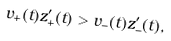<formula> <loc_0><loc_0><loc_500><loc_500>v _ { + } ( t ) z ^ { \prime } _ { + } ( t ) > v _ { - } ( t ) z ^ { \prime } _ { - } ( t ) ,</formula> 